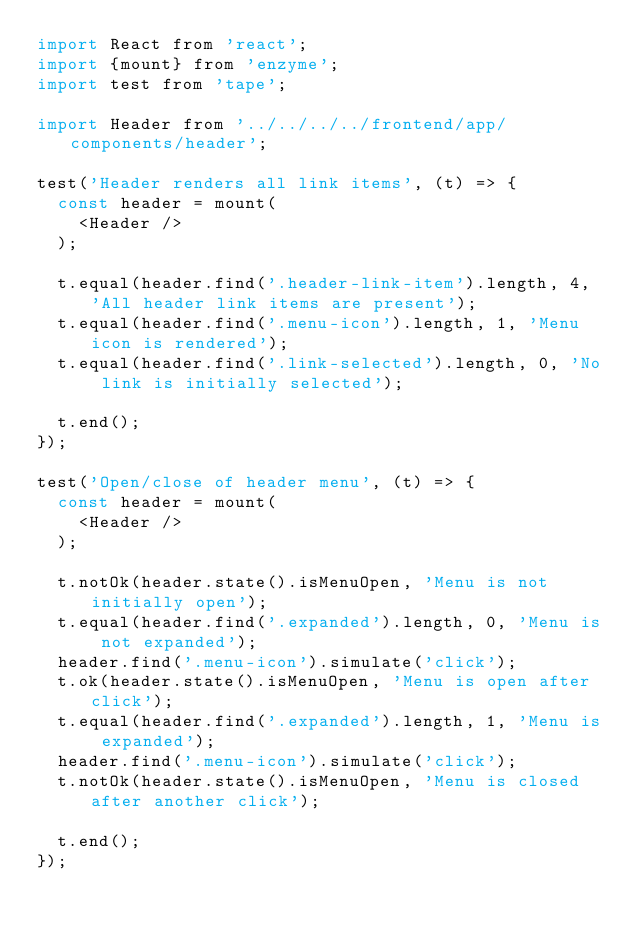Convert code to text. <code><loc_0><loc_0><loc_500><loc_500><_JavaScript_>import React from 'react';
import {mount} from 'enzyme';
import test from 'tape';

import Header from '../../../../frontend/app/components/header';

test('Header renders all link items', (t) => {
  const header = mount(
    <Header />
  );

  t.equal(header.find('.header-link-item').length, 4, 'All header link items are present');
  t.equal(header.find('.menu-icon').length, 1, 'Menu icon is rendered');
  t.equal(header.find('.link-selected').length, 0, 'No link is initially selected');

  t.end();
});

test('Open/close of header menu', (t) => {
  const header = mount(
    <Header />
  );

  t.notOk(header.state().isMenuOpen, 'Menu is not initially open');
  t.equal(header.find('.expanded').length, 0, 'Menu is not expanded');
  header.find('.menu-icon').simulate('click');
  t.ok(header.state().isMenuOpen, 'Menu is open after click');
  t.equal(header.find('.expanded').length, 1, 'Menu is expanded');
  header.find('.menu-icon').simulate('click');
  t.notOk(header.state().isMenuOpen, 'Menu is closed after another click');

  t.end();
});
</code> 